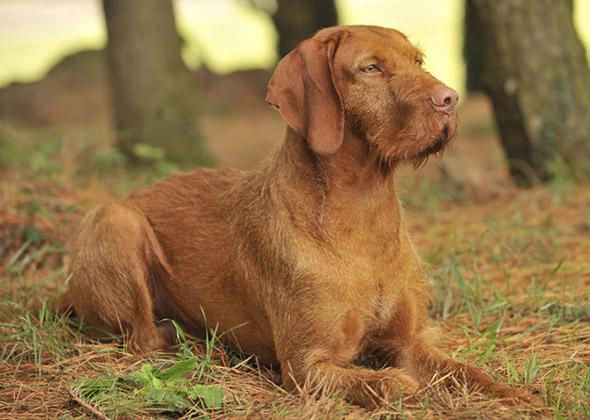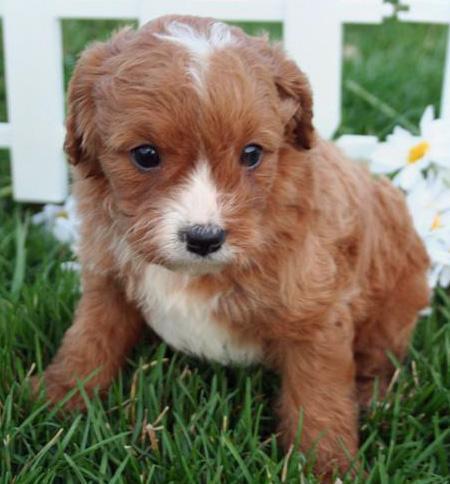The first image is the image on the left, the second image is the image on the right. Considering the images on both sides, is "The left and right image contains the same number of puppies." valid? Answer yes or no. No. The first image is the image on the left, the second image is the image on the right. Evaluate the accuracy of this statement regarding the images: "A dog is laying in grass.". Is it true? Answer yes or no. Yes. 